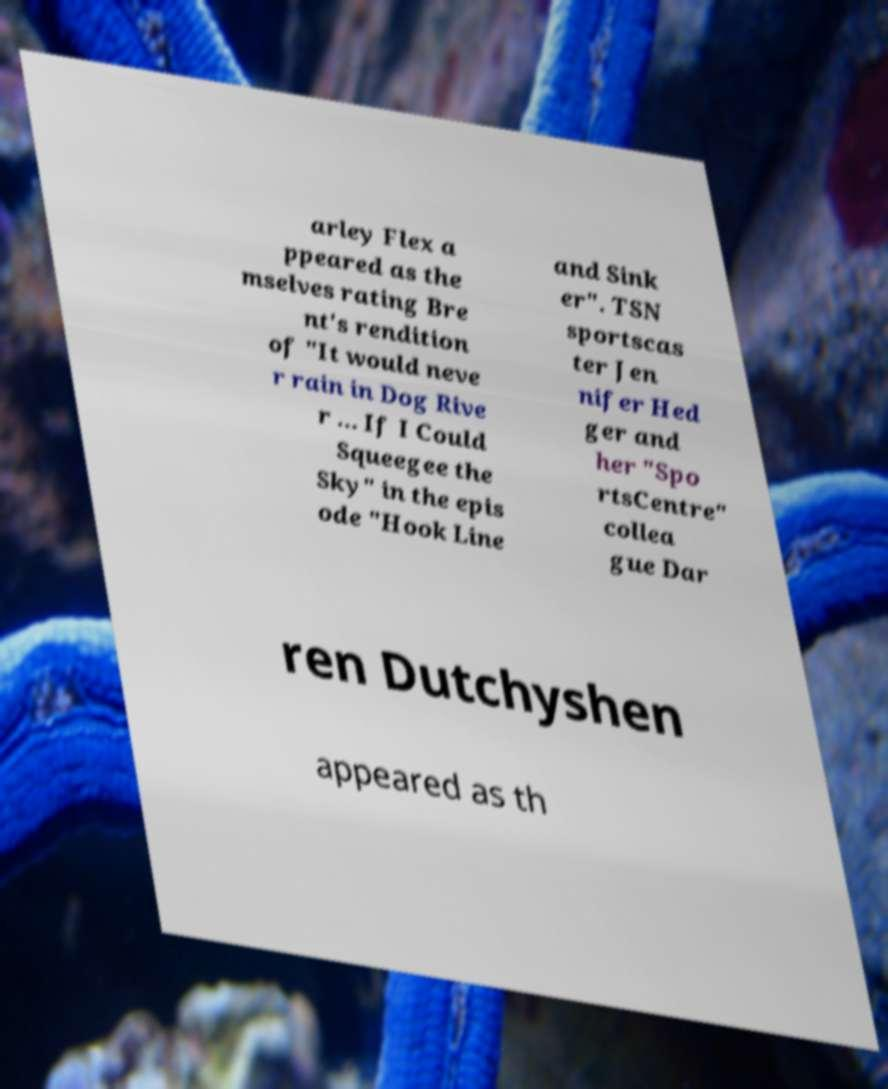Could you extract and type out the text from this image? arley Flex a ppeared as the mselves rating Bre nt's rendition of "It would neve r rain in Dog Rive r ... If I Could Squeegee the Sky" in the epis ode "Hook Line and Sink er". TSN sportscas ter Jen nifer Hed ger and her "Spo rtsCentre" collea gue Dar ren Dutchyshen appeared as th 